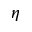Convert formula to latex. <formula><loc_0><loc_0><loc_500><loc_500>\eta</formula> 